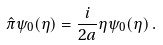Convert formula to latex. <formula><loc_0><loc_0><loc_500><loc_500>\hat { \pi } \psi _ { 0 } ( \eta ) = \frac { i } { 2 a } \eta \psi _ { 0 } ( \eta ) \, .</formula> 